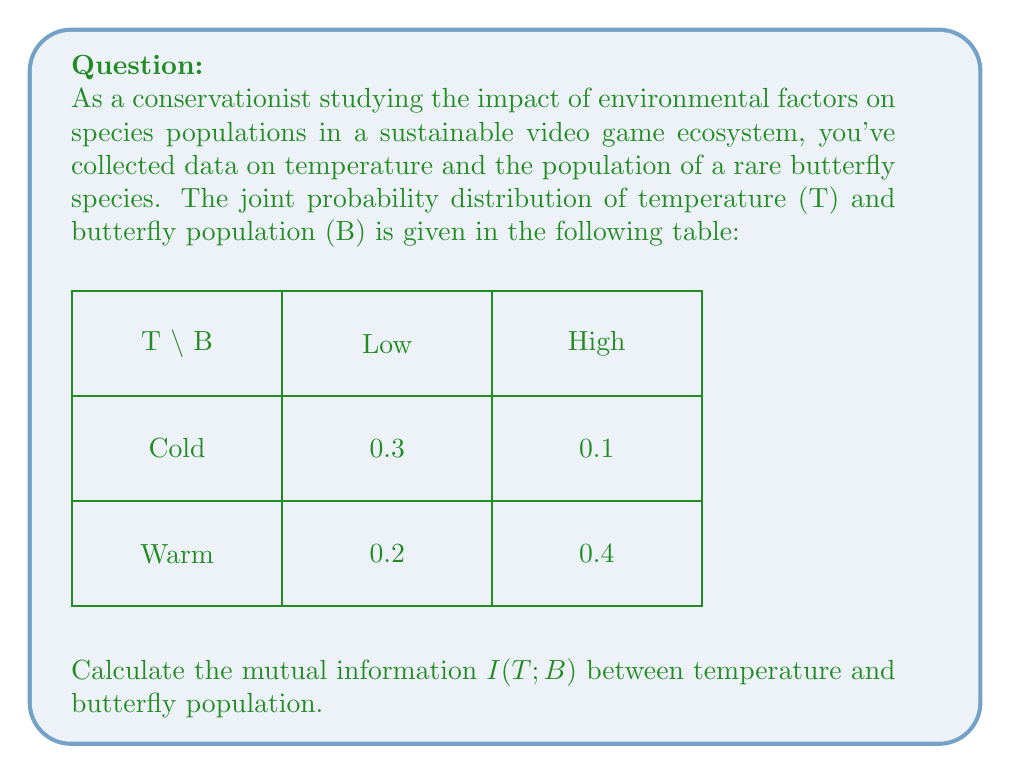Can you answer this question? To calculate the mutual information $I(T;B)$, we'll follow these steps:

1) First, let's recall the formula for mutual information:

   $I(T;B) = \sum_{t \in T} \sum_{b \in B} p(t,b) \log_2 \frac{p(t,b)}{p(t)p(b)}$

2) We need to calculate the marginal probabilities $p(t)$ and $p(b)$:

   $p(T = \text{Cold}) = 0.3 + 0.1 = 0.4$
   $p(T = \text{Warm}) = 0.2 + 0.4 = 0.6$
   $p(B = \text{Low}) = 0.3 + 0.2 = 0.5$
   $p(B = \text{High}) = 0.1 + 0.4 = 0.5$

3) Now, we can calculate each term in the sum:

   For $(T = \text{Cold}, B = \text{Low}):$
   $0.3 \log_2 \frac{0.3}{0.4 \cdot 0.5} = 0.3 \log_2 1.5 = 0.3 \cdot 0.5850 = 0.1755$

   For $(T = \text{Cold}, B = \text{High}):$
   $0.1 \log_2 \frac{0.1}{0.4 \cdot 0.5} = 0.1 \log_2 0.5 = 0.1 \cdot (-1) = -0.1$

   For $(T = \text{Warm}, B = \text{Low}):$
   $0.2 \log_2 \frac{0.2}{0.6 \cdot 0.5} = 0.2 \log_2 0.6667 = 0.2 \cdot (-0.5850) = -0.1170$

   For $(T = \text{Warm}, B = \text{High}):$
   $0.4 \log_2 \frac{0.4}{0.6 \cdot 0.5} = 0.4 \log_2 1.3333 = 0.4 \cdot 0.4150 = 0.1660$

4) Sum all these terms:

   $I(T;B) = 0.1755 + (-0.1) + (-0.1170) + 0.1660 = 0.1245$ bits

This mutual information value indicates the amount of information shared between temperature and butterfly population in this ecosystem.
Answer: $0.1245$ bits 